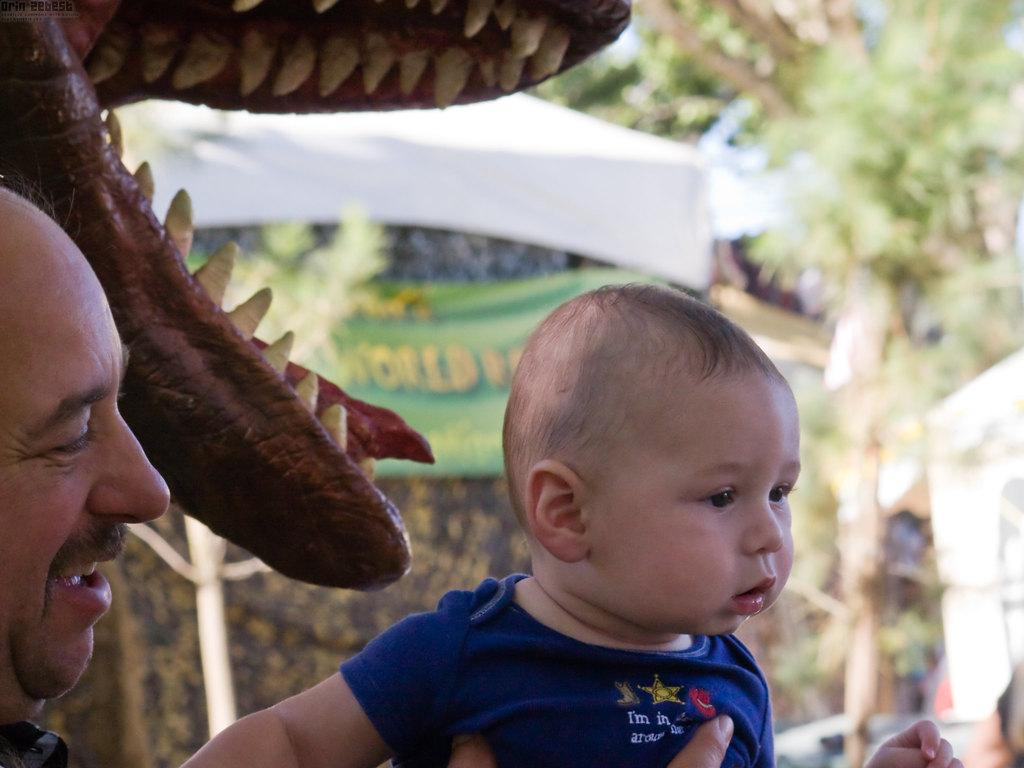What is happening in the foreground of the image? There is a person holding a boy in the foreground of the image. What can be seen in the background of the image? In the background of the image, there is a toy, an animal, tents, trees, and cars. How many different elements can be seen in the background of the image? There are six different elements visible in the background of the image: a toy, an animal, tents, trees, and cars. What attempt is the person making to learn from the animal in the image? There is no indication in the image that the person is attempting to learn from the animal. The image simply shows a person holding a boy in the foreground and various elements in the background. 